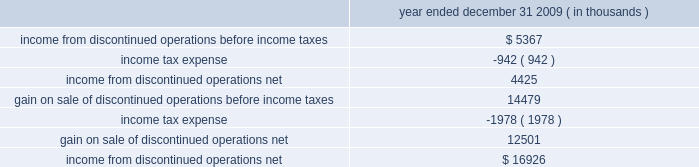$ 25.7 million in cash , including $ 4.2 million in taxes and 1373609 of hep 2019s common units having a fair value of $ 53.5 million .
Roadrunner / beeson pipelines transaction also on december 1 , 2009 , hep acquired our two newly constructed pipelines for $ 46.5 million , consisting of a 65- mile , 16-inch crude oil pipeline ( the 201croadrunner pipeline 201d ) that connects our navajo refinery lovington facility to a terminus of centurion pipeline l.p . 2019s pipeline extending between west texas and cushing , oklahoma and a 37- mile , 8-inch crude oil pipeline that connects hep 2019s new mexico crude oil gathering system to our navajo refinery lovington facility ( the 201cbeeson pipeline 201d ) .
Tulsa west loading racks transaction on august 1 , 2009 , hep acquired from us , certain truck and rail loading/unloading facilities located at our tulsa west facility for $ 17.5 million .
The racks load refined products and lube oils produced at the tulsa west facility onto rail cars and/or tanker trucks .
Lovington-artesia pipeline transaction on june 1 , 2009 , hep acquired our newly constructed , 16-inch intermediate pipeline for $ 34.2 million that runs 65 miles from our navajo refinery 2019s crude oil distillation and vacuum facilities in lovington , new mexico to its petroleum refinery located in artesia , new mexico .
Slc pipeline joint venture interest on march 1 , 2009 , hep acquired a 25% ( 25 % ) joint venture interest in the slc pipeline , a new 95-mile intrastate pipeline system jointly owned with plains .
The slc pipeline commenced operations effective march 2009 and allows various refineries in the salt lake city area , including our woods cross refinery , to ship crude oil into the salt lake city area from the utah terminus of the frontier pipeline as well as crude oil flowing from wyoming and utah via plains 2019 rocky mountain pipeline .
Hep 2019s capitalized joint venture contribution was $ 25.5 million .
Rio grande pipeline sale on december 1 , 2009 , hep sold its 70% ( 70 % ) interest in rio grande pipeline company ( 201crio grande 201d ) to a subsidiary of enterprise products partners lp for $ 35 million .
Results of operations of rio grande are presented in discontinued operations .
In accounting for this sale , hep recorded a gain of $ 14.5 million and a receivable of $ 2.2 million representing its final distribution from rio grande .
The recorded net asset balance of rio grande at december 1 , 2009 , was $ 22.7 million , consisting of cash of $ 3.1 million , $ 29.9 million in properties and equipment , net and $ 10.3 million in equity , representing bp , plc 2019s 30% ( 30 % ) noncontrolling interest .
The table provides income statement information related to hep 2019s discontinued operations : year ended december 31 , 2009 ( in thousands ) .
Transportation agreements hep serves our refineries under long-term pipeline and terminal , tankage and throughput agreements expiring in 2019 through 2026 .
Under these agreements , we pay hep fees to transport , store and throughput volumes of refined product and crude oil on hep 2019s pipeline and terminal , tankage and loading rack facilities that result in minimum annual payments to hep .
Under these agreements , the agreed upon tariff rates are subject to annual tariff rate adjustments on july 1 at a rate based upon the percentage change in producer price index ( 201cppi 201d ) or federal energy .
Excluding the gain on sale of discontinued operations , what was the income from discontinued operations , in millions? 
Computations: (16926 - 12501)
Answer: 4425.0. 